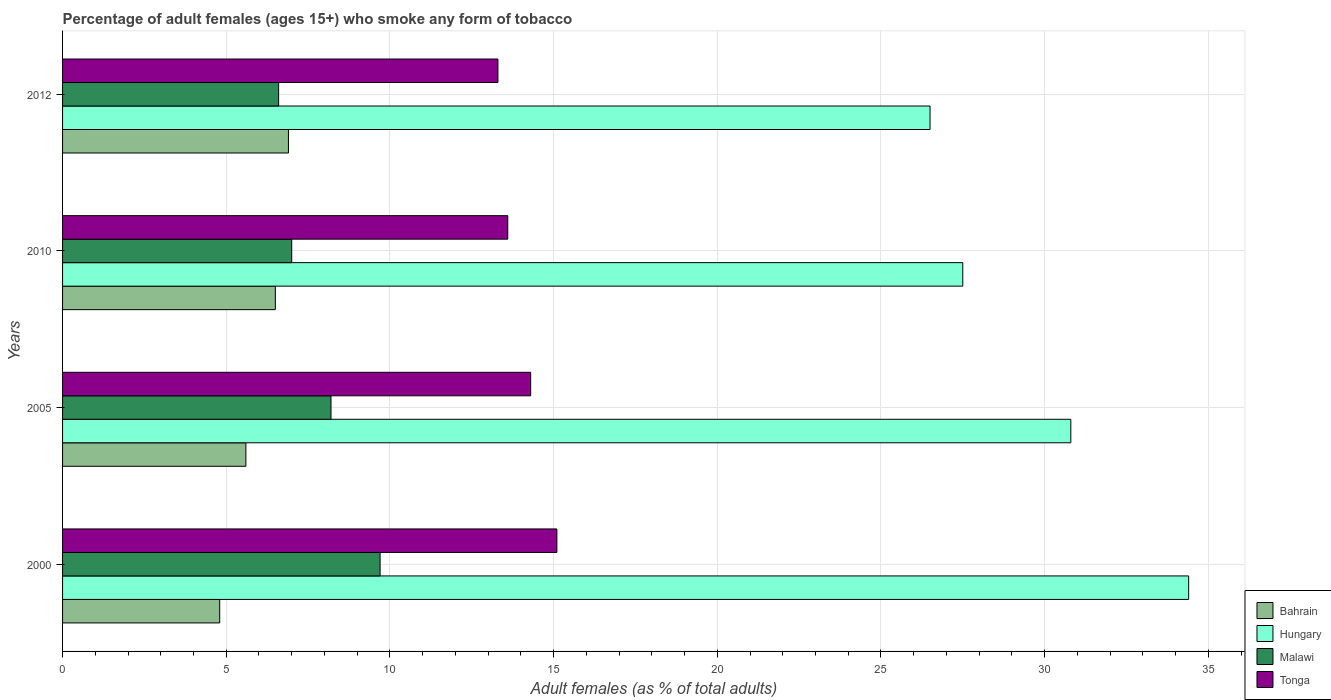How many different coloured bars are there?
Your answer should be very brief. 4. Are the number of bars on each tick of the Y-axis equal?
Offer a very short reply. Yes. How many bars are there on the 1st tick from the top?
Provide a short and direct response. 4. What is the label of the 3rd group of bars from the top?
Provide a succinct answer. 2005. In how many cases, is the number of bars for a given year not equal to the number of legend labels?
Make the answer very short. 0. What is the percentage of adult females who smoke in Malawi in 2012?
Ensure brevity in your answer.  6.6. What is the total percentage of adult females who smoke in Bahrain in the graph?
Keep it short and to the point. 23.8. What is the difference between the percentage of adult females who smoke in Bahrain in 2010 and that in 2012?
Offer a terse response. -0.4. What is the difference between the percentage of adult females who smoke in Bahrain in 2000 and the percentage of adult females who smoke in Hungary in 2012?
Make the answer very short. -21.7. What is the average percentage of adult females who smoke in Hungary per year?
Provide a short and direct response. 29.8. In the year 2005, what is the difference between the percentage of adult females who smoke in Malawi and percentage of adult females who smoke in Tonga?
Provide a short and direct response. -6.1. What is the ratio of the percentage of adult females who smoke in Tonga in 2010 to that in 2012?
Ensure brevity in your answer.  1.02. What is the difference between the highest and the second highest percentage of adult females who smoke in Malawi?
Keep it short and to the point. 1.5. What is the difference between the highest and the lowest percentage of adult females who smoke in Tonga?
Your response must be concise. 1.8. In how many years, is the percentage of adult females who smoke in Bahrain greater than the average percentage of adult females who smoke in Bahrain taken over all years?
Your answer should be compact. 2. Is the sum of the percentage of adult females who smoke in Hungary in 2000 and 2005 greater than the maximum percentage of adult females who smoke in Tonga across all years?
Provide a succinct answer. Yes. Is it the case that in every year, the sum of the percentage of adult females who smoke in Hungary and percentage of adult females who smoke in Bahrain is greater than the sum of percentage of adult females who smoke in Tonga and percentage of adult females who smoke in Malawi?
Give a very brief answer. Yes. What does the 4th bar from the top in 2010 represents?
Make the answer very short. Bahrain. What does the 2nd bar from the bottom in 2010 represents?
Keep it short and to the point. Hungary. Is it the case that in every year, the sum of the percentage of adult females who smoke in Bahrain and percentage of adult females who smoke in Hungary is greater than the percentage of adult females who smoke in Malawi?
Provide a succinct answer. Yes. Does the graph contain any zero values?
Make the answer very short. No. Does the graph contain grids?
Offer a terse response. Yes. Where does the legend appear in the graph?
Your answer should be very brief. Bottom right. What is the title of the graph?
Ensure brevity in your answer.  Percentage of adult females (ages 15+) who smoke any form of tobacco. Does "Vietnam" appear as one of the legend labels in the graph?
Offer a terse response. No. What is the label or title of the X-axis?
Offer a very short reply. Adult females (as % of total adults). What is the Adult females (as % of total adults) in Hungary in 2000?
Offer a very short reply. 34.4. What is the Adult females (as % of total adults) of Malawi in 2000?
Your answer should be compact. 9.7. What is the Adult females (as % of total adults) in Tonga in 2000?
Your response must be concise. 15.1. What is the Adult females (as % of total adults) of Bahrain in 2005?
Offer a very short reply. 5.6. What is the Adult females (as % of total adults) of Hungary in 2005?
Your answer should be very brief. 30.8. What is the Adult females (as % of total adults) of Bahrain in 2010?
Your response must be concise. 6.5. What is the Adult females (as % of total adults) of Tonga in 2010?
Your answer should be very brief. 13.6. What is the Adult females (as % of total adults) in Hungary in 2012?
Provide a succinct answer. 26.5. What is the Adult females (as % of total adults) in Malawi in 2012?
Your answer should be compact. 6.6. What is the Adult females (as % of total adults) of Tonga in 2012?
Your answer should be compact. 13.3. Across all years, what is the maximum Adult females (as % of total adults) of Hungary?
Give a very brief answer. 34.4. Across all years, what is the minimum Adult females (as % of total adults) of Hungary?
Provide a short and direct response. 26.5. Across all years, what is the minimum Adult females (as % of total adults) in Malawi?
Give a very brief answer. 6.6. What is the total Adult females (as % of total adults) in Bahrain in the graph?
Provide a short and direct response. 23.8. What is the total Adult females (as % of total adults) in Hungary in the graph?
Provide a short and direct response. 119.2. What is the total Adult females (as % of total adults) of Malawi in the graph?
Provide a short and direct response. 31.5. What is the total Adult females (as % of total adults) of Tonga in the graph?
Keep it short and to the point. 56.3. What is the difference between the Adult females (as % of total adults) of Bahrain in 2000 and that in 2005?
Your response must be concise. -0.8. What is the difference between the Adult females (as % of total adults) of Tonga in 2000 and that in 2005?
Offer a very short reply. 0.8. What is the difference between the Adult females (as % of total adults) of Bahrain in 2000 and that in 2010?
Provide a succinct answer. -1.7. What is the difference between the Adult females (as % of total adults) in Hungary in 2000 and that in 2010?
Your response must be concise. 6.9. What is the difference between the Adult females (as % of total adults) of Tonga in 2000 and that in 2012?
Ensure brevity in your answer.  1.8. What is the difference between the Adult females (as % of total adults) of Hungary in 2005 and that in 2010?
Ensure brevity in your answer.  3.3. What is the difference between the Adult females (as % of total adults) of Tonga in 2005 and that in 2010?
Give a very brief answer. 0.7. What is the difference between the Adult females (as % of total adults) of Bahrain in 2005 and that in 2012?
Offer a very short reply. -1.3. What is the difference between the Adult females (as % of total adults) of Hungary in 2005 and that in 2012?
Your answer should be compact. 4.3. What is the difference between the Adult females (as % of total adults) in Malawi in 2005 and that in 2012?
Ensure brevity in your answer.  1.6. What is the difference between the Adult females (as % of total adults) of Bahrain in 2010 and that in 2012?
Ensure brevity in your answer.  -0.4. What is the difference between the Adult females (as % of total adults) of Malawi in 2010 and that in 2012?
Provide a short and direct response. 0.4. What is the difference between the Adult females (as % of total adults) of Tonga in 2010 and that in 2012?
Ensure brevity in your answer.  0.3. What is the difference between the Adult females (as % of total adults) in Bahrain in 2000 and the Adult females (as % of total adults) in Hungary in 2005?
Offer a very short reply. -26. What is the difference between the Adult females (as % of total adults) in Bahrain in 2000 and the Adult females (as % of total adults) in Tonga in 2005?
Keep it short and to the point. -9.5. What is the difference between the Adult females (as % of total adults) of Hungary in 2000 and the Adult females (as % of total adults) of Malawi in 2005?
Provide a succinct answer. 26.2. What is the difference between the Adult females (as % of total adults) in Hungary in 2000 and the Adult females (as % of total adults) in Tonga in 2005?
Your answer should be very brief. 20.1. What is the difference between the Adult females (as % of total adults) of Bahrain in 2000 and the Adult females (as % of total adults) of Hungary in 2010?
Offer a very short reply. -22.7. What is the difference between the Adult females (as % of total adults) of Hungary in 2000 and the Adult females (as % of total adults) of Malawi in 2010?
Make the answer very short. 27.4. What is the difference between the Adult females (as % of total adults) of Hungary in 2000 and the Adult females (as % of total adults) of Tonga in 2010?
Offer a very short reply. 20.8. What is the difference between the Adult females (as % of total adults) of Bahrain in 2000 and the Adult females (as % of total adults) of Hungary in 2012?
Keep it short and to the point. -21.7. What is the difference between the Adult females (as % of total adults) of Hungary in 2000 and the Adult females (as % of total adults) of Malawi in 2012?
Ensure brevity in your answer.  27.8. What is the difference between the Adult females (as % of total adults) of Hungary in 2000 and the Adult females (as % of total adults) of Tonga in 2012?
Ensure brevity in your answer.  21.1. What is the difference between the Adult females (as % of total adults) of Malawi in 2000 and the Adult females (as % of total adults) of Tonga in 2012?
Offer a very short reply. -3.6. What is the difference between the Adult females (as % of total adults) of Bahrain in 2005 and the Adult females (as % of total adults) of Hungary in 2010?
Your answer should be very brief. -21.9. What is the difference between the Adult females (as % of total adults) of Hungary in 2005 and the Adult females (as % of total adults) of Malawi in 2010?
Keep it short and to the point. 23.8. What is the difference between the Adult females (as % of total adults) in Malawi in 2005 and the Adult females (as % of total adults) in Tonga in 2010?
Keep it short and to the point. -5.4. What is the difference between the Adult females (as % of total adults) of Bahrain in 2005 and the Adult females (as % of total adults) of Hungary in 2012?
Give a very brief answer. -20.9. What is the difference between the Adult females (as % of total adults) of Bahrain in 2005 and the Adult females (as % of total adults) of Malawi in 2012?
Keep it short and to the point. -1. What is the difference between the Adult females (as % of total adults) of Hungary in 2005 and the Adult females (as % of total adults) of Malawi in 2012?
Ensure brevity in your answer.  24.2. What is the difference between the Adult females (as % of total adults) of Bahrain in 2010 and the Adult females (as % of total adults) of Hungary in 2012?
Offer a very short reply. -20. What is the difference between the Adult females (as % of total adults) in Hungary in 2010 and the Adult females (as % of total adults) in Malawi in 2012?
Offer a very short reply. 20.9. What is the difference between the Adult females (as % of total adults) in Malawi in 2010 and the Adult females (as % of total adults) in Tonga in 2012?
Keep it short and to the point. -6.3. What is the average Adult females (as % of total adults) in Bahrain per year?
Provide a succinct answer. 5.95. What is the average Adult females (as % of total adults) in Hungary per year?
Keep it short and to the point. 29.8. What is the average Adult females (as % of total adults) in Malawi per year?
Make the answer very short. 7.88. What is the average Adult females (as % of total adults) of Tonga per year?
Give a very brief answer. 14.07. In the year 2000, what is the difference between the Adult females (as % of total adults) of Bahrain and Adult females (as % of total adults) of Hungary?
Provide a succinct answer. -29.6. In the year 2000, what is the difference between the Adult females (as % of total adults) in Bahrain and Adult females (as % of total adults) in Tonga?
Provide a succinct answer. -10.3. In the year 2000, what is the difference between the Adult females (as % of total adults) in Hungary and Adult females (as % of total adults) in Malawi?
Your answer should be very brief. 24.7. In the year 2000, what is the difference between the Adult females (as % of total adults) of Hungary and Adult females (as % of total adults) of Tonga?
Provide a succinct answer. 19.3. In the year 2000, what is the difference between the Adult females (as % of total adults) in Malawi and Adult females (as % of total adults) in Tonga?
Give a very brief answer. -5.4. In the year 2005, what is the difference between the Adult females (as % of total adults) in Bahrain and Adult females (as % of total adults) in Hungary?
Make the answer very short. -25.2. In the year 2005, what is the difference between the Adult females (as % of total adults) of Hungary and Adult females (as % of total adults) of Malawi?
Provide a succinct answer. 22.6. In the year 2005, what is the difference between the Adult females (as % of total adults) of Hungary and Adult females (as % of total adults) of Tonga?
Your answer should be very brief. 16.5. In the year 2005, what is the difference between the Adult females (as % of total adults) of Malawi and Adult females (as % of total adults) of Tonga?
Make the answer very short. -6.1. In the year 2010, what is the difference between the Adult females (as % of total adults) of Bahrain and Adult females (as % of total adults) of Tonga?
Offer a terse response. -7.1. In the year 2010, what is the difference between the Adult females (as % of total adults) in Hungary and Adult females (as % of total adults) in Malawi?
Offer a very short reply. 20.5. In the year 2010, what is the difference between the Adult females (as % of total adults) of Hungary and Adult females (as % of total adults) of Tonga?
Provide a short and direct response. 13.9. In the year 2010, what is the difference between the Adult females (as % of total adults) of Malawi and Adult females (as % of total adults) of Tonga?
Offer a very short reply. -6.6. In the year 2012, what is the difference between the Adult females (as % of total adults) of Bahrain and Adult females (as % of total adults) of Hungary?
Your response must be concise. -19.6. In the year 2012, what is the difference between the Adult females (as % of total adults) in Hungary and Adult females (as % of total adults) in Tonga?
Provide a short and direct response. 13.2. In the year 2012, what is the difference between the Adult females (as % of total adults) in Malawi and Adult females (as % of total adults) in Tonga?
Your answer should be very brief. -6.7. What is the ratio of the Adult females (as % of total adults) of Bahrain in 2000 to that in 2005?
Your response must be concise. 0.86. What is the ratio of the Adult females (as % of total adults) of Hungary in 2000 to that in 2005?
Ensure brevity in your answer.  1.12. What is the ratio of the Adult females (as % of total adults) of Malawi in 2000 to that in 2005?
Your answer should be compact. 1.18. What is the ratio of the Adult females (as % of total adults) in Tonga in 2000 to that in 2005?
Make the answer very short. 1.06. What is the ratio of the Adult females (as % of total adults) of Bahrain in 2000 to that in 2010?
Ensure brevity in your answer.  0.74. What is the ratio of the Adult females (as % of total adults) in Hungary in 2000 to that in 2010?
Give a very brief answer. 1.25. What is the ratio of the Adult females (as % of total adults) in Malawi in 2000 to that in 2010?
Offer a terse response. 1.39. What is the ratio of the Adult females (as % of total adults) in Tonga in 2000 to that in 2010?
Ensure brevity in your answer.  1.11. What is the ratio of the Adult females (as % of total adults) in Bahrain in 2000 to that in 2012?
Provide a succinct answer. 0.7. What is the ratio of the Adult females (as % of total adults) of Hungary in 2000 to that in 2012?
Provide a short and direct response. 1.3. What is the ratio of the Adult females (as % of total adults) of Malawi in 2000 to that in 2012?
Keep it short and to the point. 1.47. What is the ratio of the Adult females (as % of total adults) of Tonga in 2000 to that in 2012?
Your response must be concise. 1.14. What is the ratio of the Adult females (as % of total adults) in Bahrain in 2005 to that in 2010?
Your answer should be compact. 0.86. What is the ratio of the Adult females (as % of total adults) of Hungary in 2005 to that in 2010?
Make the answer very short. 1.12. What is the ratio of the Adult females (as % of total adults) in Malawi in 2005 to that in 2010?
Your response must be concise. 1.17. What is the ratio of the Adult females (as % of total adults) of Tonga in 2005 to that in 2010?
Give a very brief answer. 1.05. What is the ratio of the Adult females (as % of total adults) in Bahrain in 2005 to that in 2012?
Make the answer very short. 0.81. What is the ratio of the Adult females (as % of total adults) of Hungary in 2005 to that in 2012?
Offer a terse response. 1.16. What is the ratio of the Adult females (as % of total adults) of Malawi in 2005 to that in 2012?
Your answer should be compact. 1.24. What is the ratio of the Adult females (as % of total adults) of Tonga in 2005 to that in 2012?
Give a very brief answer. 1.08. What is the ratio of the Adult females (as % of total adults) of Bahrain in 2010 to that in 2012?
Offer a very short reply. 0.94. What is the ratio of the Adult females (as % of total adults) in Hungary in 2010 to that in 2012?
Your answer should be compact. 1.04. What is the ratio of the Adult females (as % of total adults) in Malawi in 2010 to that in 2012?
Ensure brevity in your answer.  1.06. What is the ratio of the Adult females (as % of total adults) of Tonga in 2010 to that in 2012?
Your response must be concise. 1.02. What is the difference between the highest and the second highest Adult females (as % of total adults) of Bahrain?
Offer a terse response. 0.4. What is the difference between the highest and the second highest Adult females (as % of total adults) in Malawi?
Your answer should be compact. 1.5. What is the difference between the highest and the lowest Adult females (as % of total adults) in Bahrain?
Offer a terse response. 2.1. What is the difference between the highest and the lowest Adult females (as % of total adults) in Hungary?
Provide a short and direct response. 7.9. What is the difference between the highest and the lowest Adult females (as % of total adults) of Malawi?
Your response must be concise. 3.1. What is the difference between the highest and the lowest Adult females (as % of total adults) in Tonga?
Offer a terse response. 1.8. 